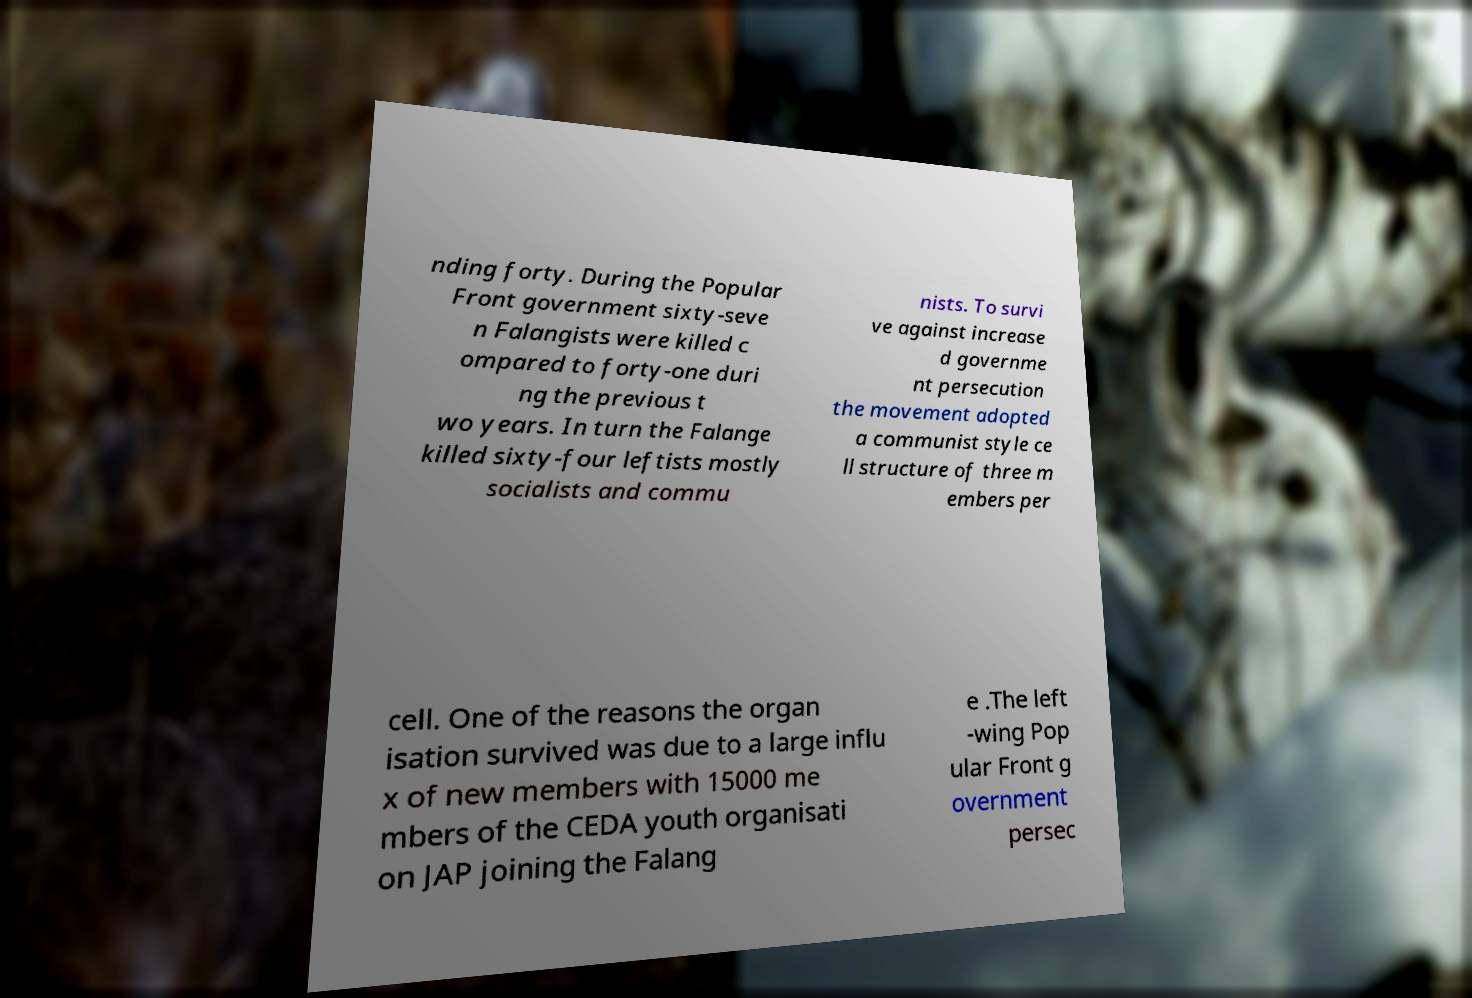Please identify and transcribe the text found in this image. nding forty. During the Popular Front government sixty-seve n Falangists were killed c ompared to forty-one duri ng the previous t wo years. In turn the Falange killed sixty-four leftists mostly socialists and commu nists. To survi ve against increase d governme nt persecution the movement adopted a communist style ce ll structure of three m embers per cell. One of the reasons the organ isation survived was due to a large influ x of new members with 15000 me mbers of the CEDA youth organisati on JAP joining the Falang e .The left -wing Pop ular Front g overnment persec 